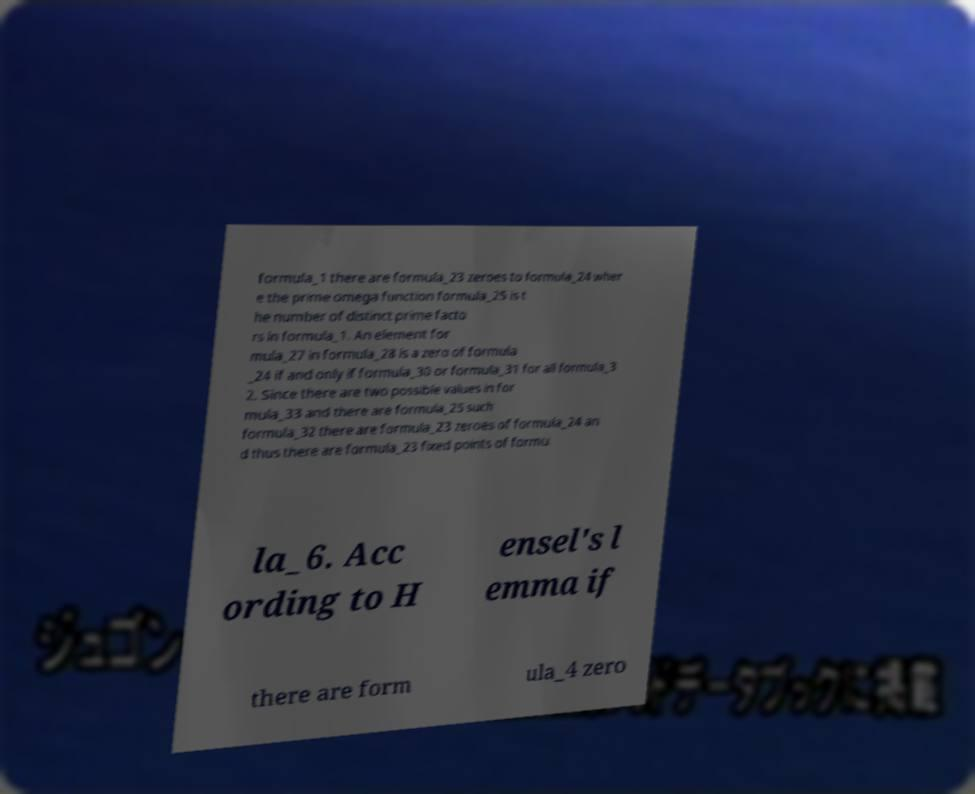Can you read and provide the text displayed in the image?This photo seems to have some interesting text. Can you extract and type it out for me? formula_1 there are formula_23 zeroes to formula_24 wher e the prime omega function formula_25 is t he number of distinct prime facto rs in formula_1. An element for mula_27 in formula_28 is a zero of formula _24 if and only if formula_30 or formula_31 for all formula_3 2. Since there are two possible values in for mula_33 and there are formula_25 such formula_32 there are formula_23 zeroes of formula_24 an d thus there are formula_23 fixed points of formu la_6. Acc ording to H ensel's l emma if there are form ula_4 zero 